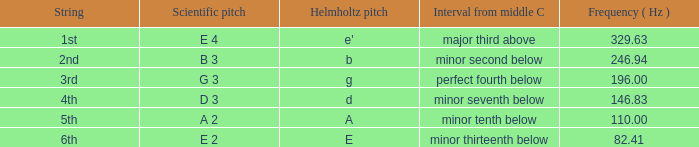What is the scientific pitch when the Helmholtz pitch is D? D 3. 